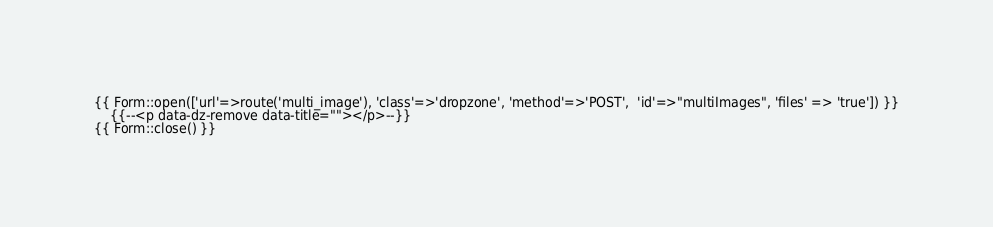<code> <loc_0><loc_0><loc_500><loc_500><_PHP_>{{ Form::open(['url'=>route('multi_image'), 'class'=>'dropzone', 'method'=>'POST',  'id'=>"multiImages", 'files' => 'true']) }}
	{{--<p data-dz-remove data-title=""></p>--}}
{{ Form::close() }}
</code> 